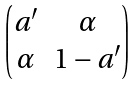Convert formula to latex. <formula><loc_0><loc_0><loc_500><loc_500>\begin{pmatrix} a ^ { \prime } & \alpha \\ \alpha & 1 - a ^ { \prime } \end{pmatrix}</formula> 